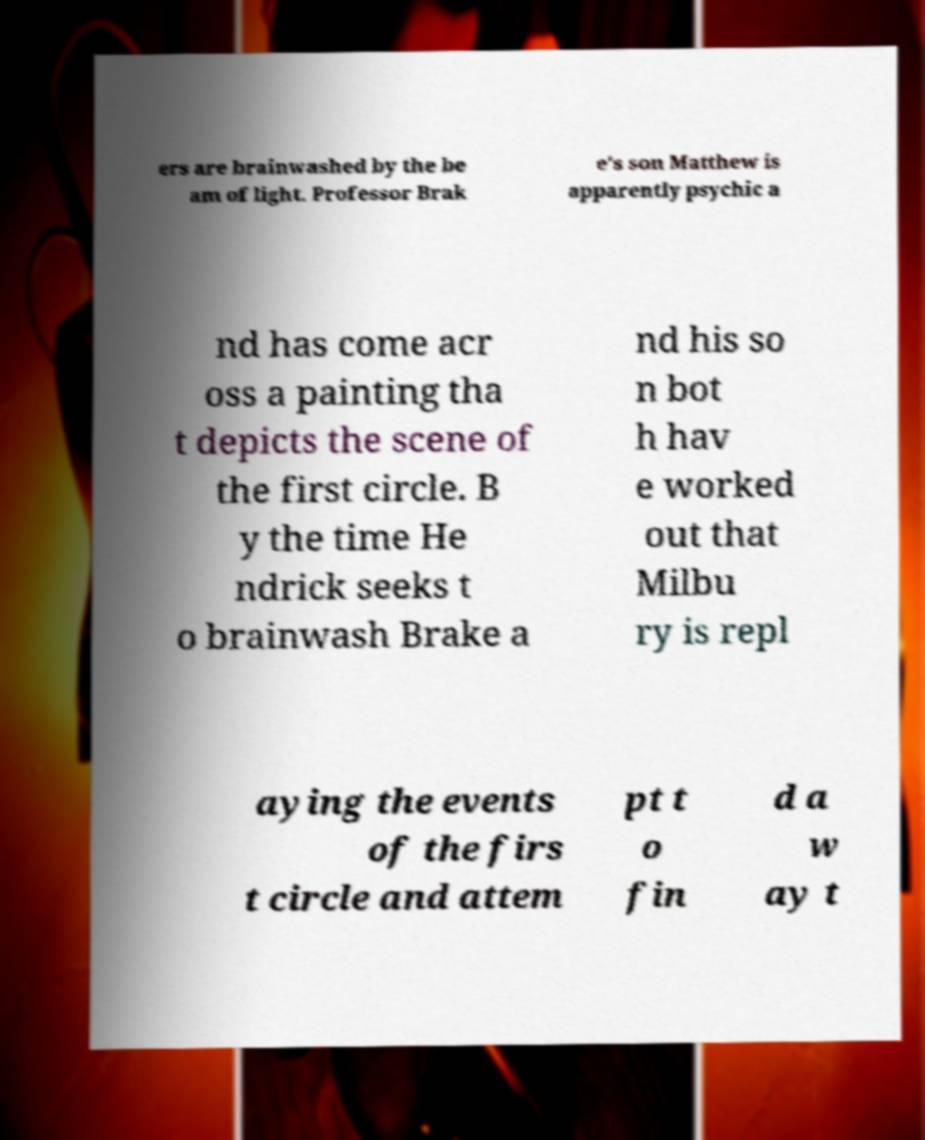I need the written content from this picture converted into text. Can you do that? ers are brainwashed by the be am of light. Professor Brak e's son Matthew is apparently psychic a nd has come acr oss a painting tha t depicts the scene of the first circle. B y the time He ndrick seeks t o brainwash Brake a nd his so n bot h hav e worked out that Milbu ry is repl aying the events of the firs t circle and attem pt t o fin d a w ay t 